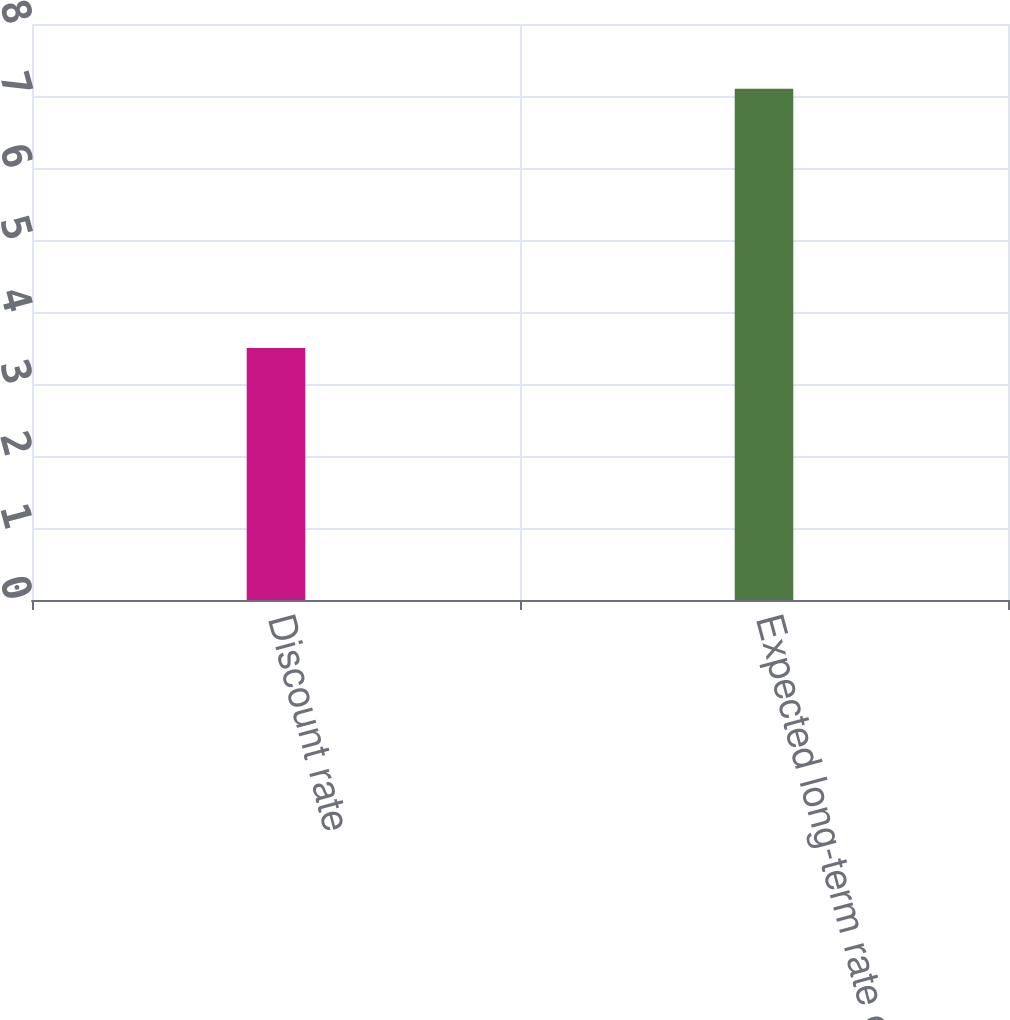<chart> <loc_0><loc_0><loc_500><loc_500><bar_chart><fcel>Discount rate<fcel>Expected long-term rate of<nl><fcel>3.5<fcel>7.1<nl></chart> 